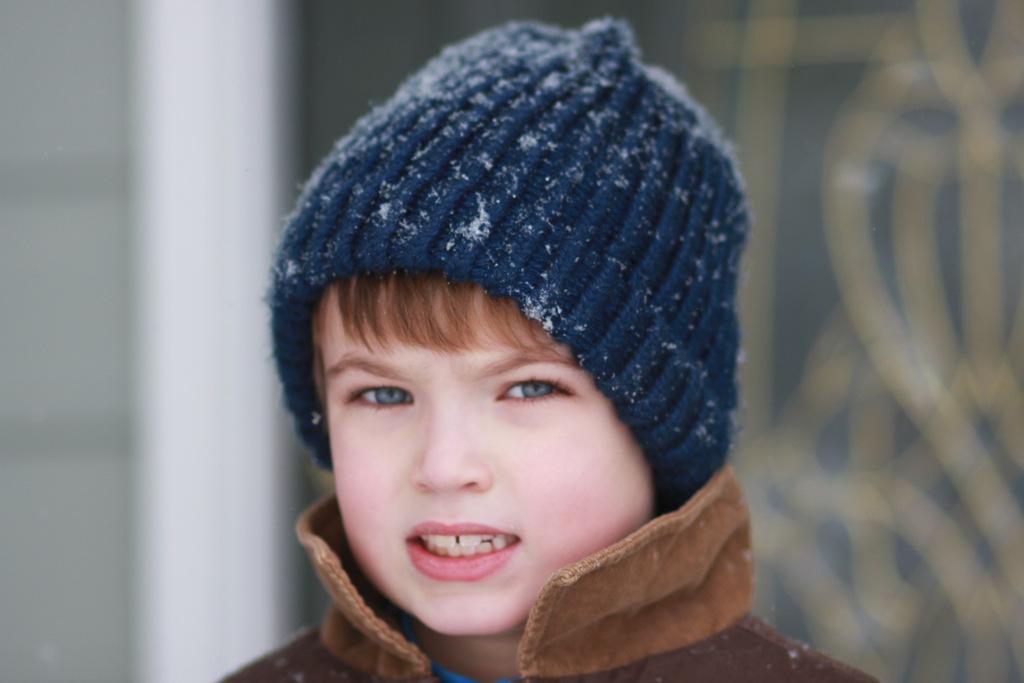How would you summarize this image in a sentence or two? In the image we can see there is a kid, he is wearing jacket and head cap. There are snow particles on the head cap. 